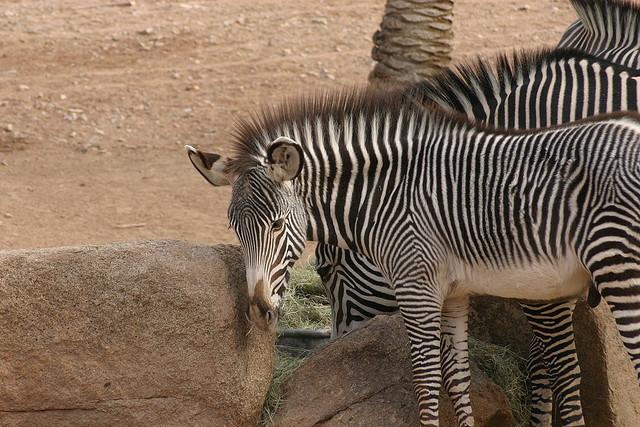What design is the zebra's coat?
Give a very brief answer. Striped. Where is the zebra?
Concise answer only. Zoo. Is the Zebra about to run?
Keep it brief. No. 